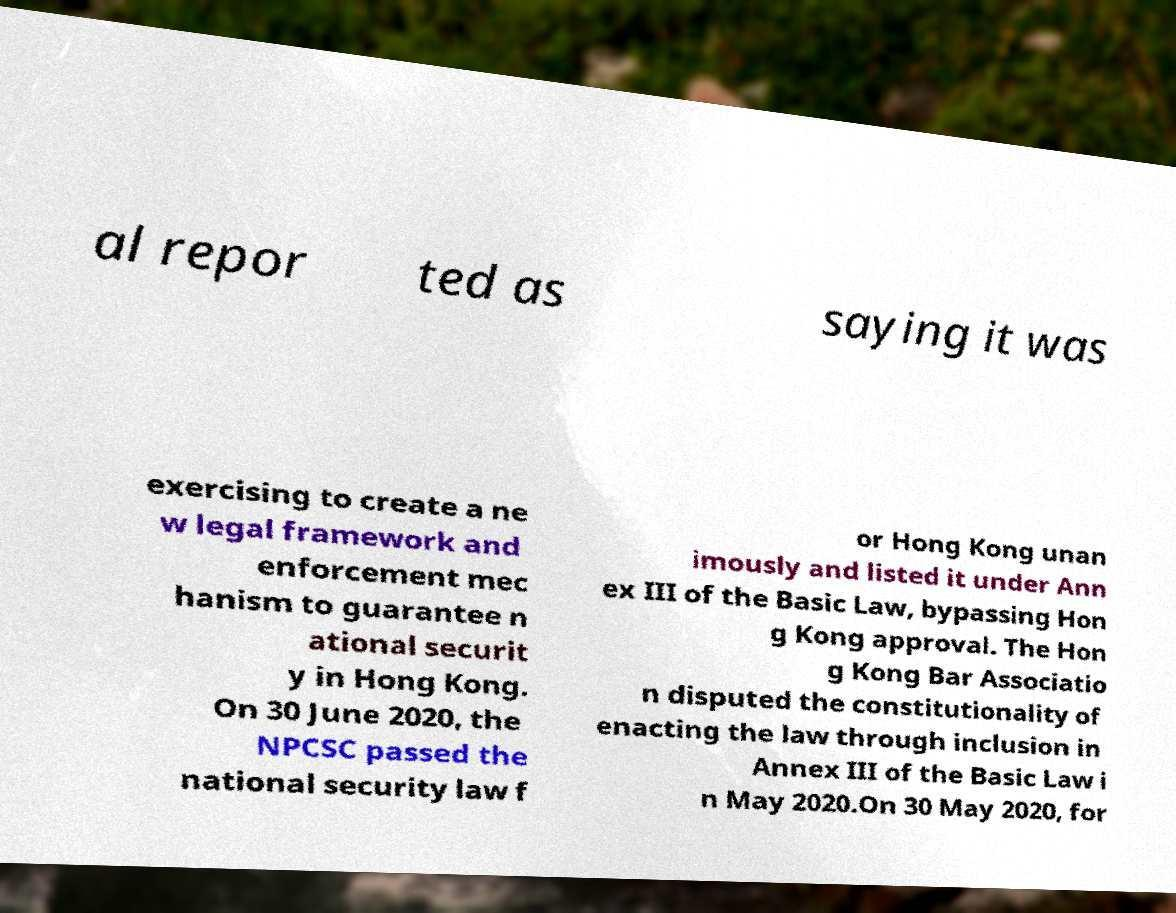There's text embedded in this image that I need extracted. Can you transcribe it verbatim? al repor ted as saying it was exercising to create a ne w legal framework and enforcement mec hanism to guarantee n ational securit y in Hong Kong. On 30 June 2020, the NPCSC passed the national security law f or Hong Kong unan imously and listed it under Ann ex III of the Basic Law, bypassing Hon g Kong approval. The Hon g Kong Bar Associatio n disputed the constitutionality of enacting the law through inclusion in Annex III of the Basic Law i n May 2020.On 30 May 2020, for 